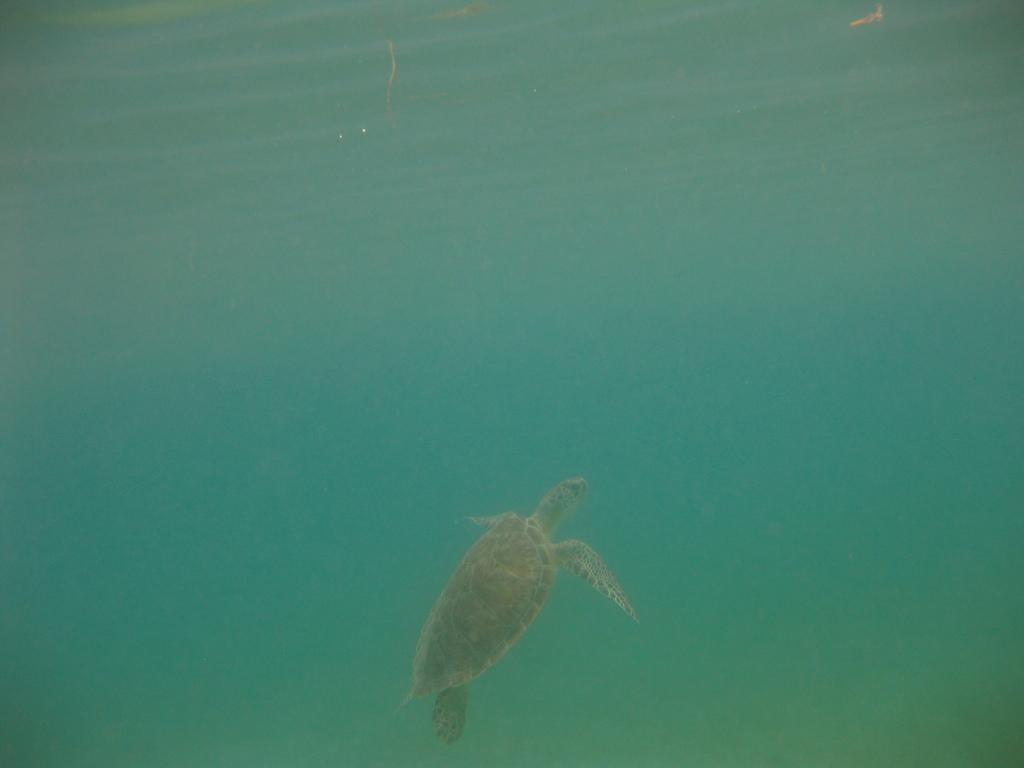Describe this image in one or two sentences. In this image we can see a tortoise in the water. 